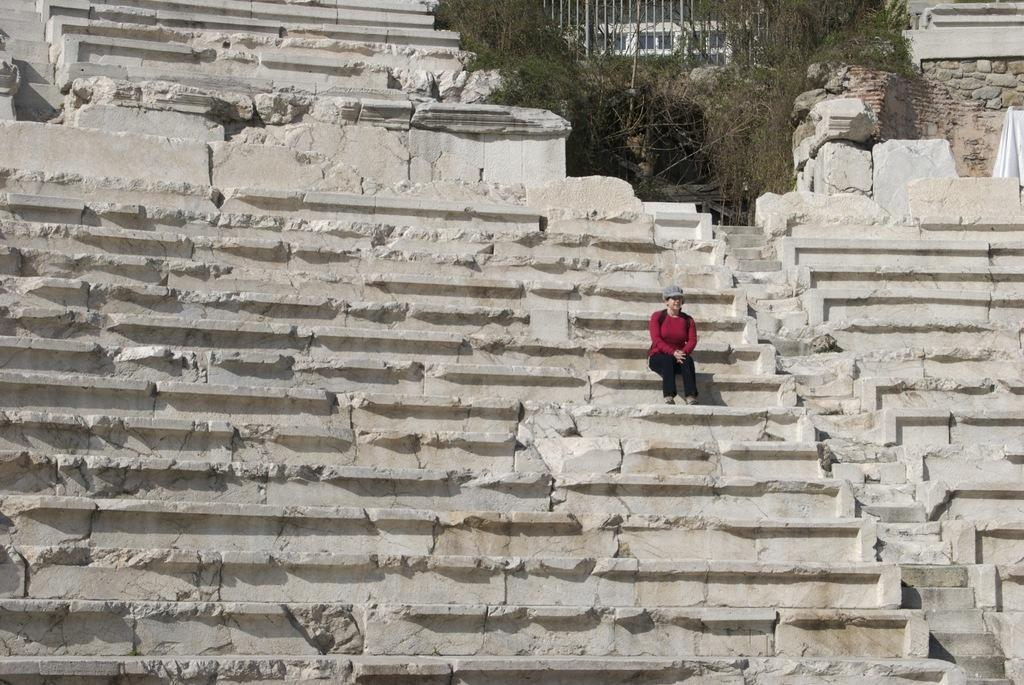What is the person in the image doing? The person is sitting on stairs in the image. What can be seen in the background of the image? There are trees and a building in the background of the image. What type of kettle is visible in the image? There is no kettle present in the image. How does the heat affect the person sitting on the stairs in the image? The image does not provide any information about the temperature or heat, so we cannot determine how it affects the person sitting on the stairs. 